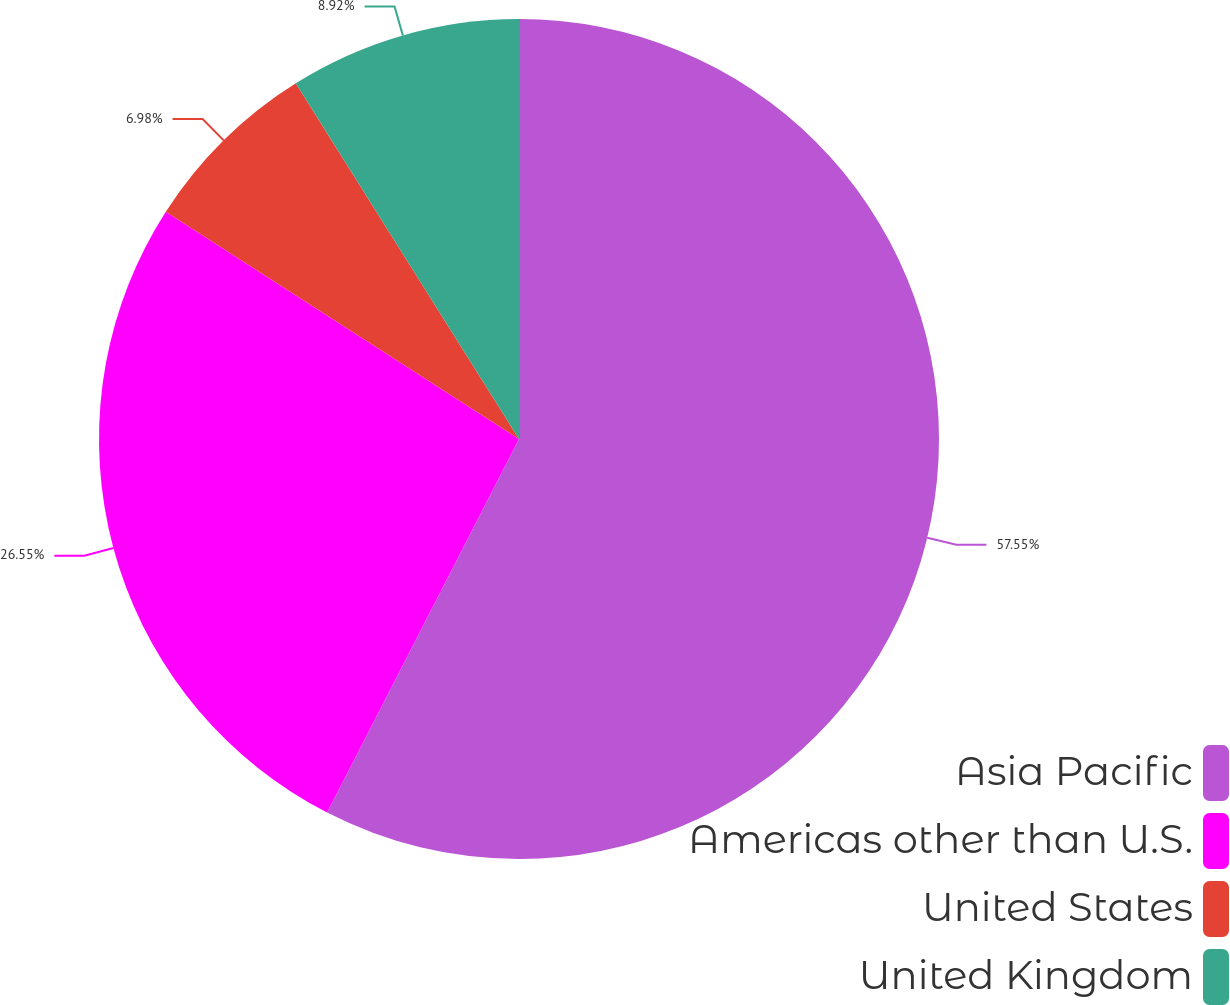Convert chart. <chart><loc_0><loc_0><loc_500><loc_500><pie_chart><fcel>Asia Pacific<fcel>Americas other than U.S.<fcel>United States<fcel>United Kingdom<nl><fcel>57.55%<fcel>26.55%<fcel>6.98%<fcel>8.92%<nl></chart> 